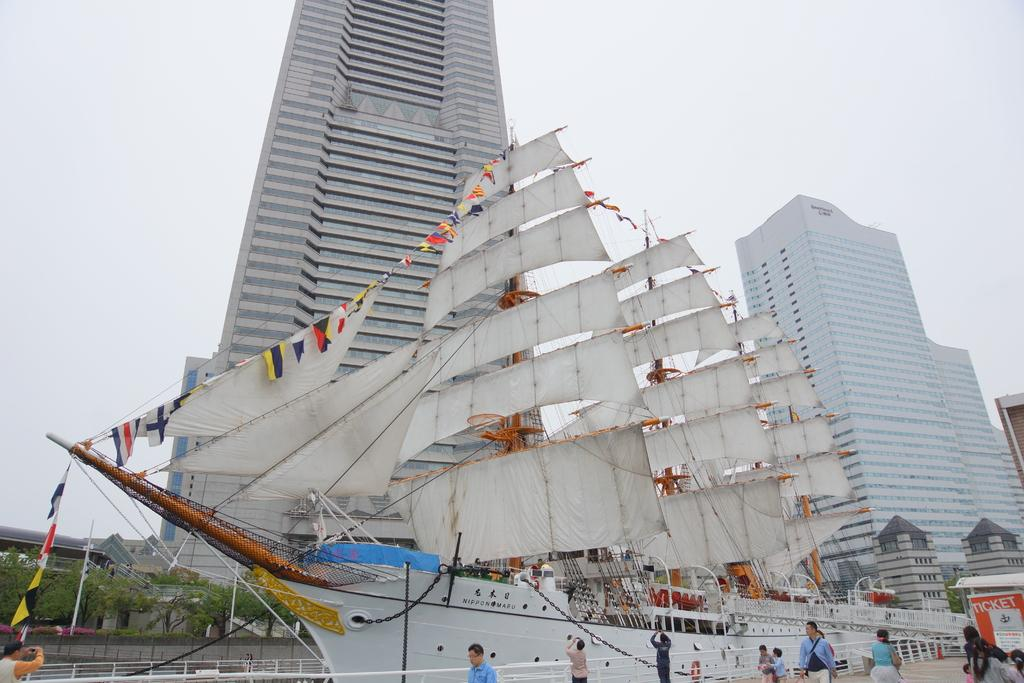What type of structures can be seen in the image? There are buildings in the image. What mode of transportation is present in the image? There is a ship in the image. Are there any people visible in the image? Yes, there are people in the image. What type of barrier can be seen in the image? There is fencing in the image. What type of signage is present in the image? There are posters in the image. What type of vegetation is visible in the image? There are trees in the image. What part of the natural environment is visible in the image? The sky is visible in the image. What type of songs can be heard coming from the buildings in the image? There is no indication in the image that any songs are being played or heard. 